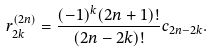<formula> <loc_0><loc_0><loc_500><loc_500>r _ { 2 k } ^ { ( 2 n ) } = \frac { ( - 1 ) ^ { k } ( 2 n + 1 ) ! } { ( 2 n - 2 k ) ! } c _ { 2 n - 2 k } .</formula> 